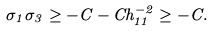<formula> <loc_0><loc_0><loc_500><loc_500>\sigma _ { 1 } \sigma _ { 3 } \geq - C - C h _ { 1 1 } ^ { - 2 } \geq - C .</formula> 